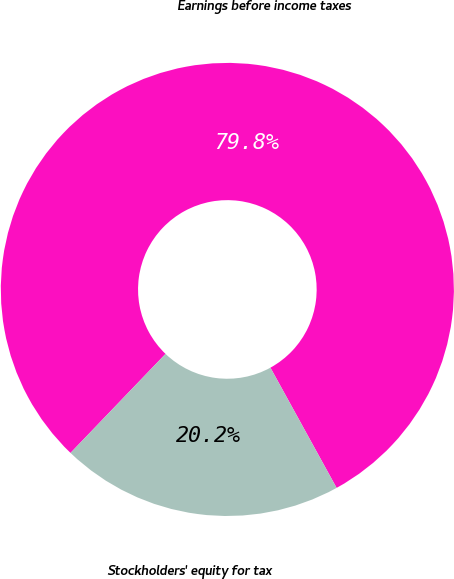Convert chart to OTSL. <chart><loc_0><loc_0><loc_500><loc_500><pie_chart><fcel>Earnings before income taxes<fcel>Stockholders' equity for tax<nl><fcel>79.82%<fcel>20.18%<nl></chart> 